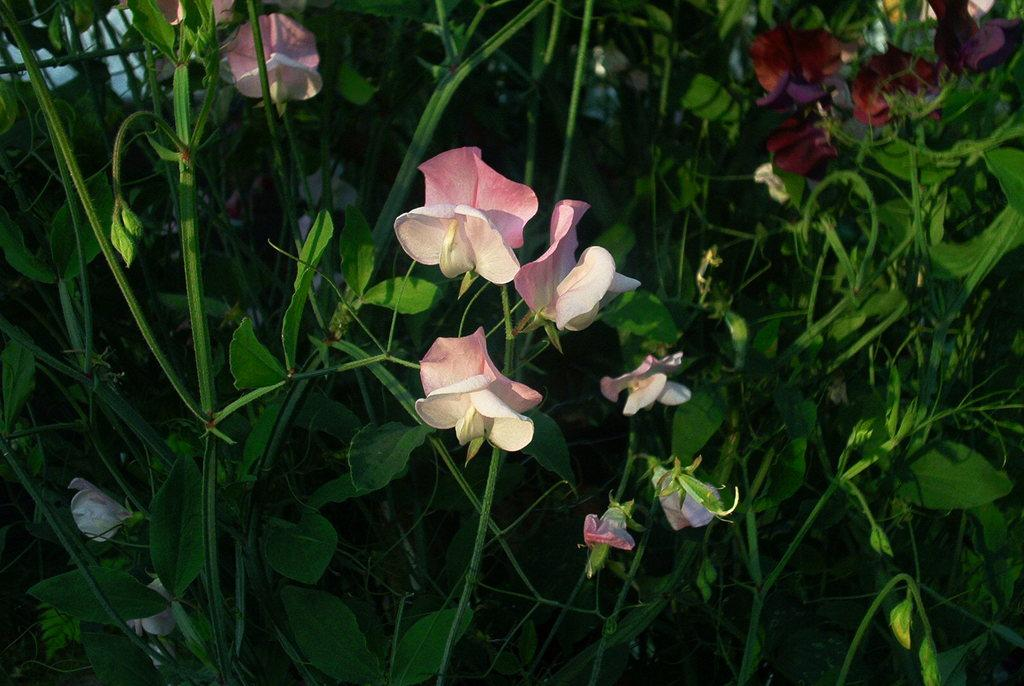What type of flora can be seen in the image? There are flowers in the image. What can be seen in the background of the image? There are plants in the background of the image. What thrilling decision must be made while driving on the road in the image? There is no road or driving depicted in the image; it features flowers and plants. 